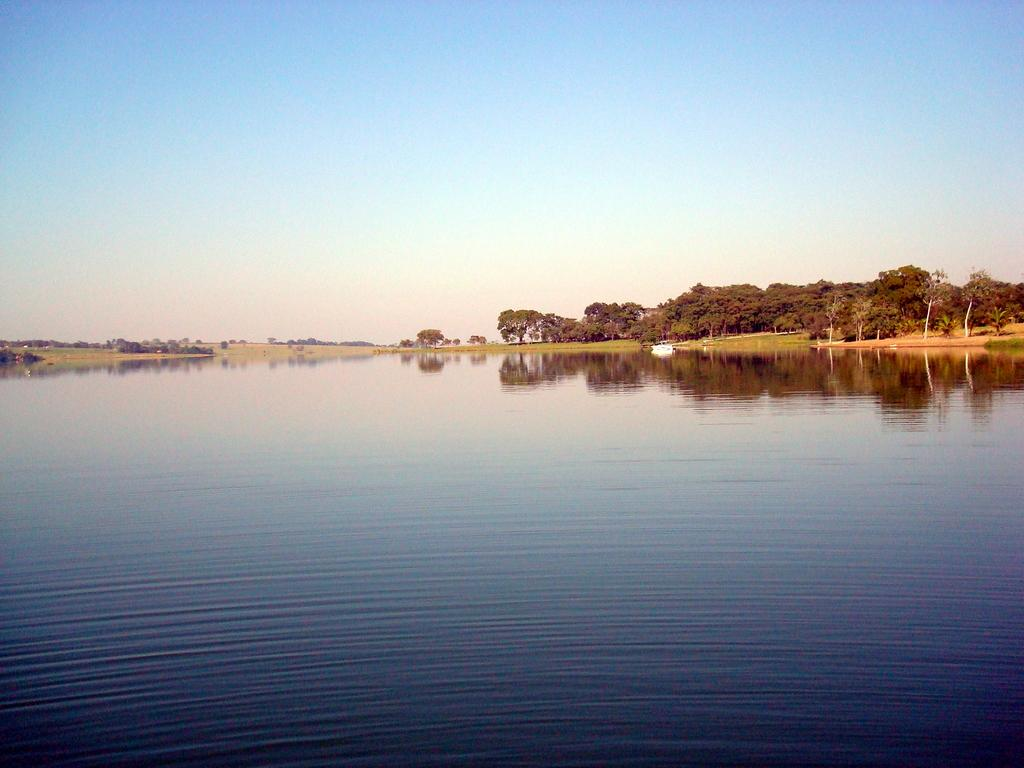What is one of the natural elements present in the image? There is water in the image. What type of vegetation can be seen in the image? There is grass and a plant in the image. What is the color of the sky in the image? The sky is pale blue in the image. Can you describe the object in the water? There is an object in the water, but its specific details are not mentioned in the facts. How does the plant help the prisoners escape from the flight in the image? There is no mention of a flight, prisoners, or an escape attempt in the image. The image only features water, grass, a plant, and a pale blue sky. 